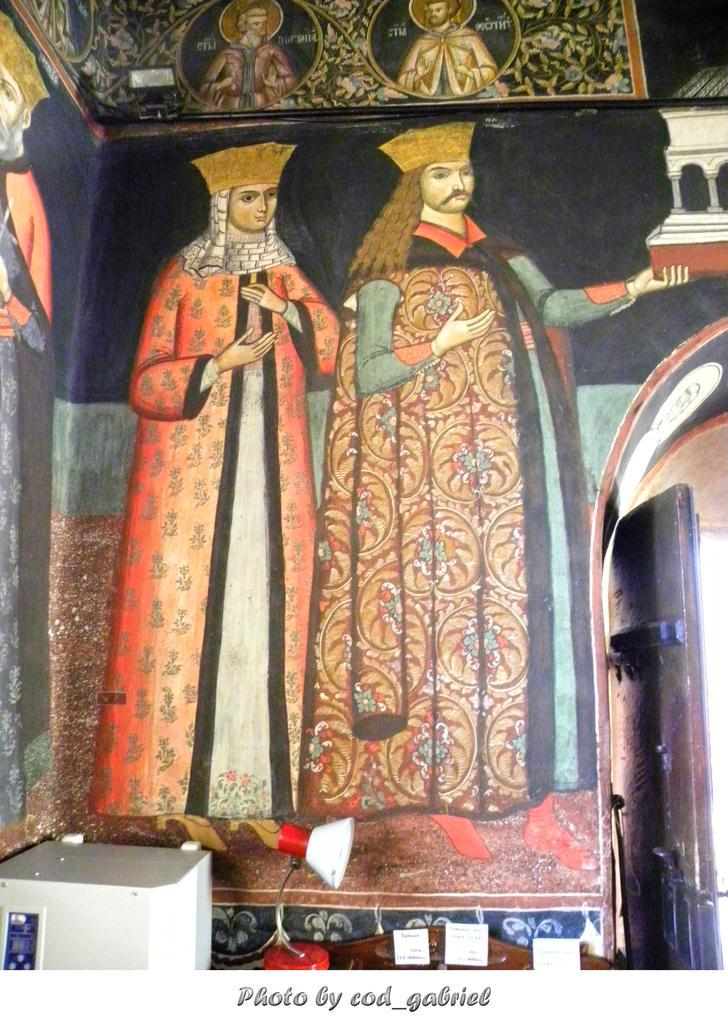Describe this image in one or two sentences. In this image I can see a wall, on the wall I can see two persons. The person at right wearing brown dress and the person at left wearing orange and cream color dress. 